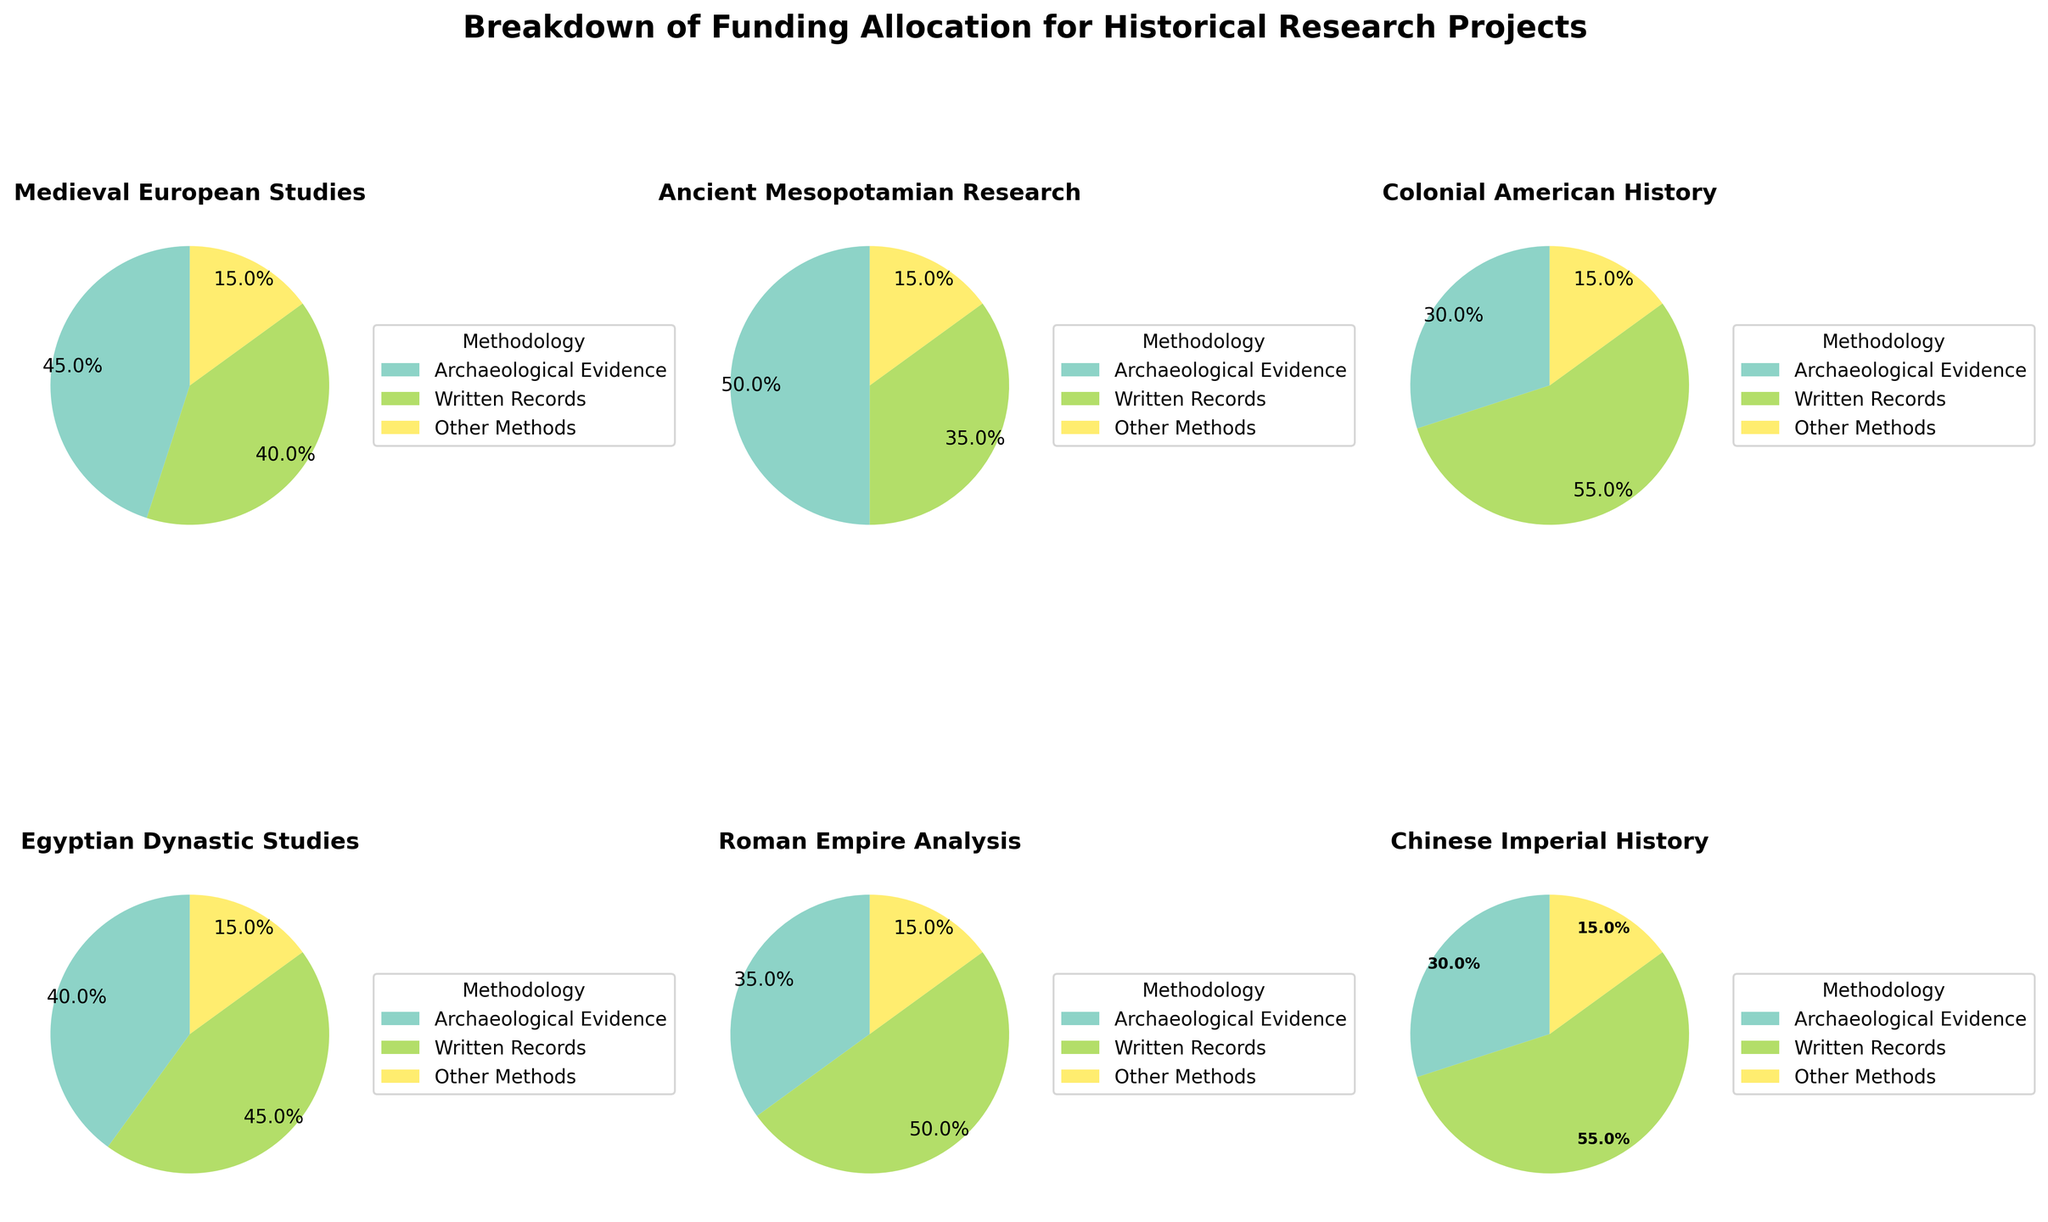what is the title of the plot? The title of the plot is written at the top of the figure.
Answer: Breakdown of Funding Allocation for Historical Research Projects How many pie charts are displayed in total? Each subplot contains one pie chart, and there are 6 subplots in total.
Answer: 6 Which historical research project allocates the highest percentage to Written Records? Identify the pie chart with the largest segment for Written Records. The Colonial American History and Chinese Imperial History projects both allocate 55% to Written Records.
Answer: Colonial American History and Chinese Imperial History (55%) What percentage of funding does Egyptian Dynastic Studies allocate to Archaeological Evidence? Look at the segment labeled for Egyptian Dynastic Studies.
Answer: 40% Which project has the smallest percentage allocated to Archaeological Evidence? Compare the percentages allocated to Archaeological Evidence across all pie charts.
Answer: Colonial American History and Chinese Imperial History (30%) Calculate the average percentage of funding allocation for Archaeological Evidence across all projects. Add the percentages for Archaeological Evidence for all projects and divide by the number of projects. (45+50+30+40+35+30)/6
Answer: 38.3% If you combine the funding for Written Records in Medieval European Studies and Roman Empire Analysis, what is the total percentage? Sum the percentages of Written Records for the specified projects. (40% + 50%)
Answer: 90% Compare the allocation to Other Methods across the projects. Are they the same or different? Look at the "Other Methods" segment for each pie chart. All segments for Other Methods are the same.
Answer: The same (15% each) Which project has an equal allocation of funding between Archaeological Evidence and Written Records? Look for a pie chart where the percentages for Archaeological Evidence and Written Records are equal.
Answer: Egyptian Dynastic Studies (40% each) For Ancient Mesopotamian Research, what is the difference in percentage between Archaeological Evidence and Written Records? Subtract the percentage of Written Records from the percentage of Archaeological Evidence for Ancient Mesopotamian Research. (50% - 35%)
Answer: 15% 